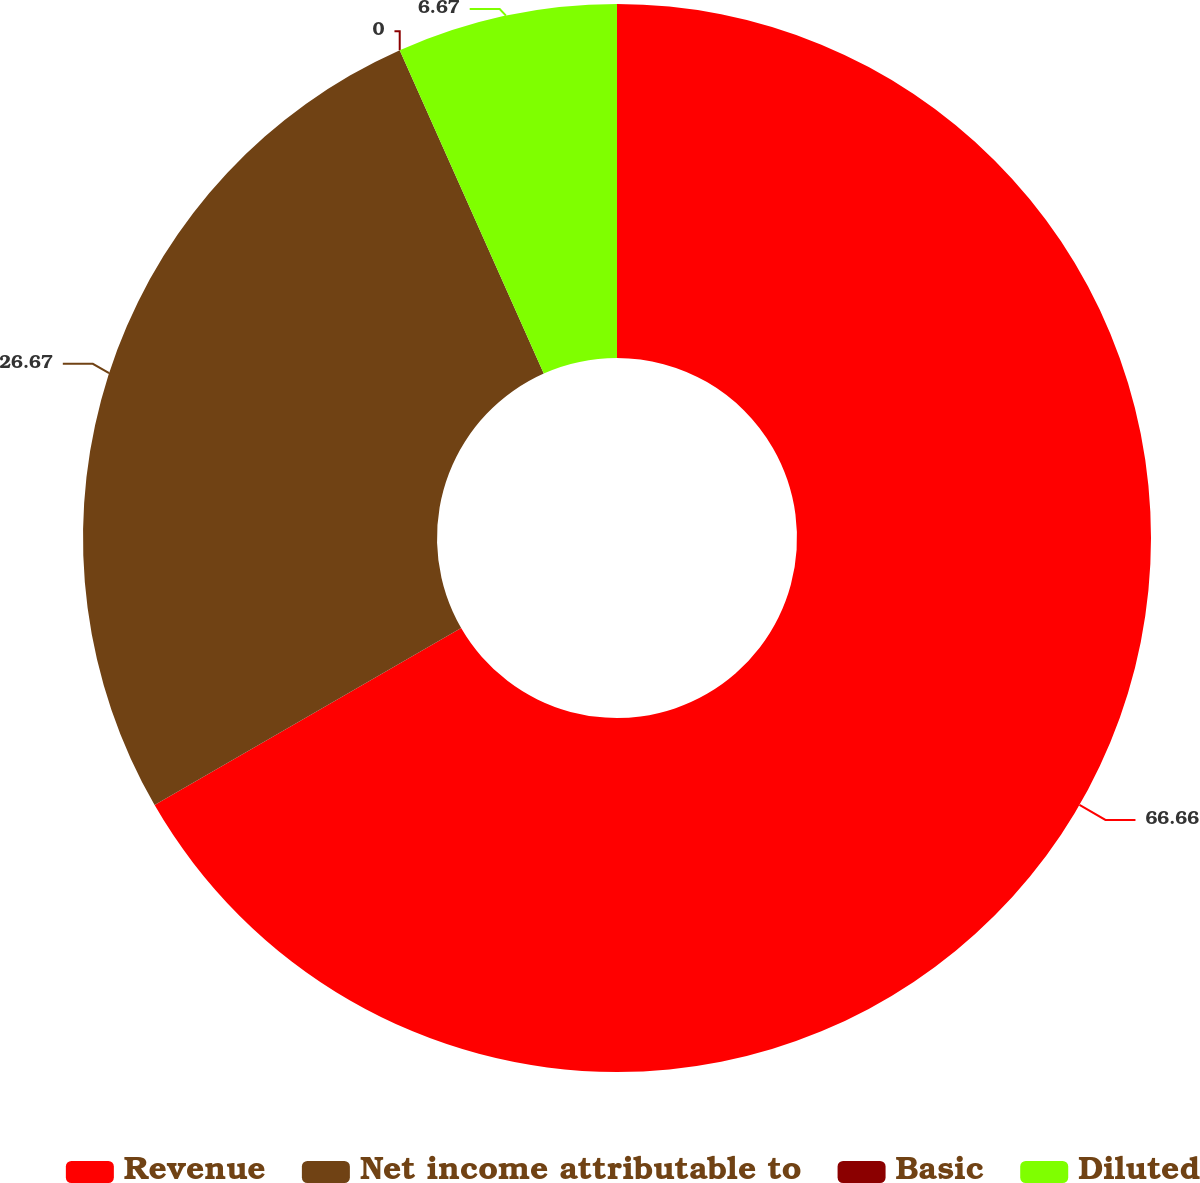Convert chart to OTSL. <chart><loc_0><loc_0><loc_500><loc_500><pie_chart><fcel>Revenue<fcel>Net income attributable to<fcel>Basic<fcel>Diluted<nl><fcel>66.67%<fcel>26.67%<fcel>0.0%<fcel>6.67%<nl></chart> 